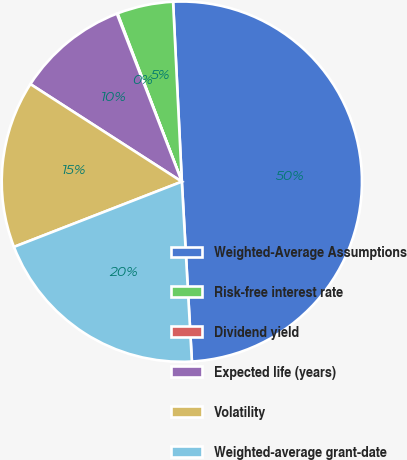Convert chart. <chart><loc_0><loc_0><loc_500><loc_500><pie_chart><fcel>Weighted-Average Assumptions<fcel>Risk-free interest rate<fcel>Dividend yield<fcel>Expected life (years)<fcel>Volatility<fcel>Weighted-average grant-date<nl><fcel>49.89%<fcel>5.04%<fcel>0.06%<fcel>10.02%<fcel>15.01%<fcel>19.99%<nl></chart> 